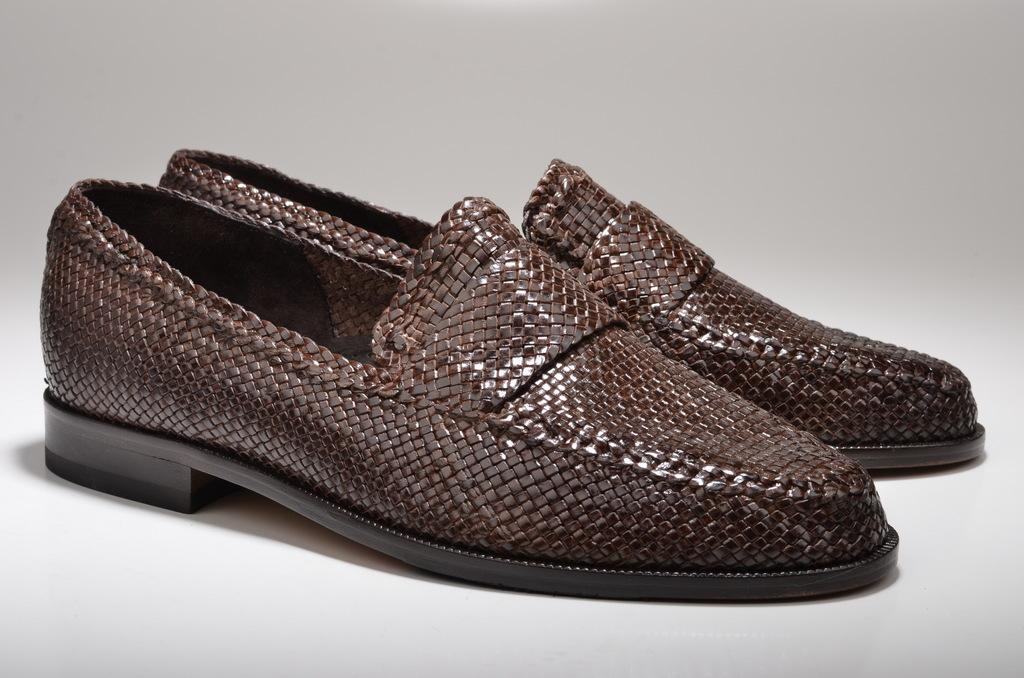What type of objects are on the floor in the image? There are footwear in the image. Where are the footwear located? The footwear is on the floor. What is the color of the floor? The floor is white in color. What type of sign is the maid holding in the image? There is no maid or sign present in the image. The image only features footwear on a white floor. 